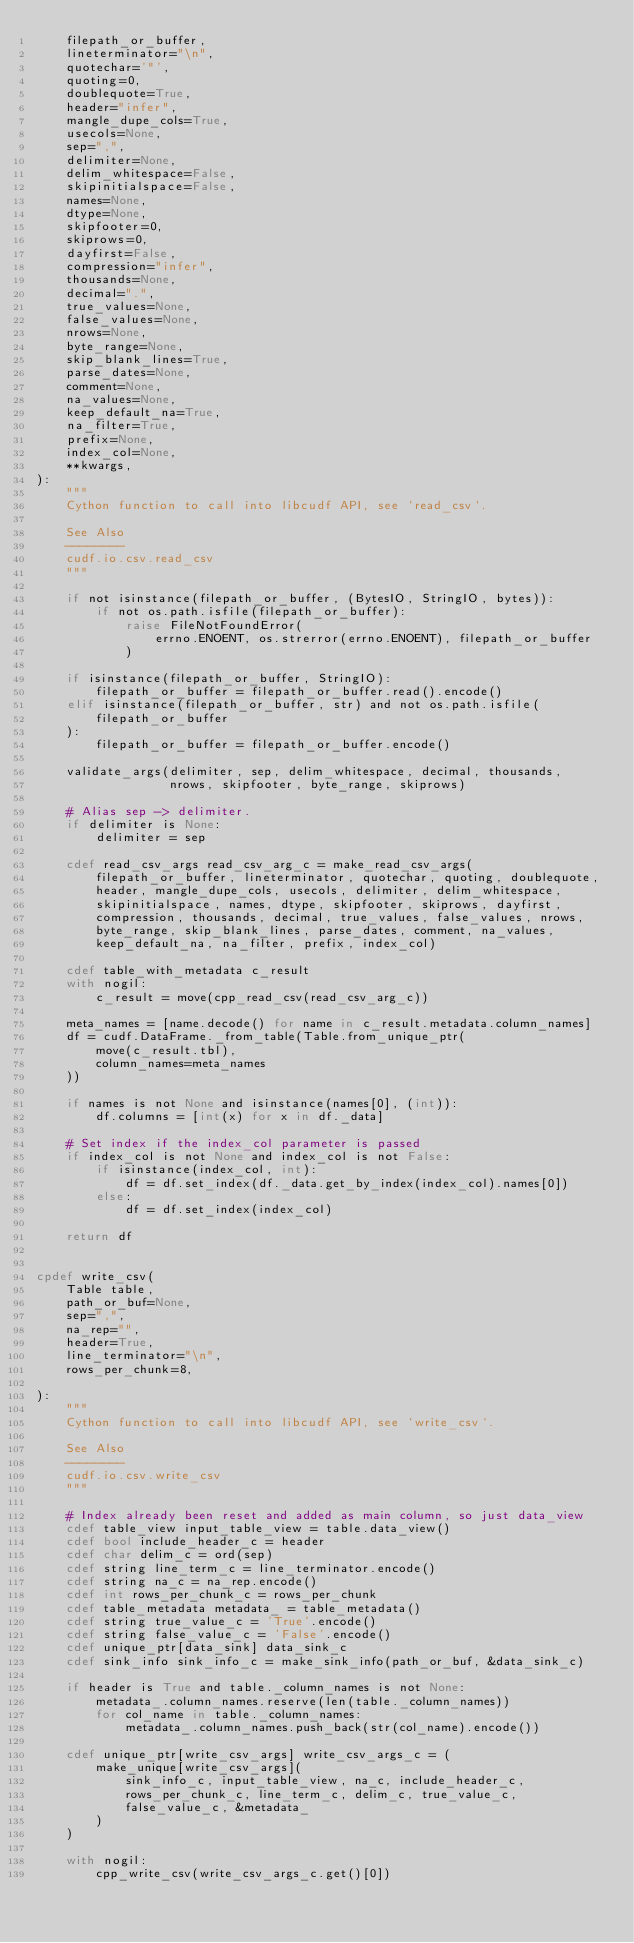<code> <loc_0><loc_0><loc_500><loc_500><_Cython_>    filepath_or_buffer,
    lineterminator="\n",
    quotechar='"',
    quoting=0,
    doublequote=True,
    header="infer",
    mangle_dupe_cols=True,
    usecols=None,
    sep=",",
    delimiter=None,
    delim_whitespace=False,
    skipinitialspace=False,
    names=None,
    dtype=None,
    skipfooter=0,
    skiprows=0,
    dayfirst=False,
    compression="infer",
    thousands=None,
    decimal=".",
    true_values=None,
    false_values=None,
    nrows=None,
    byte_range=None,
    skip_blank_lines=True,
    parse_dates=None,
    comment=None,
    na_values=None,
    keep_default_na=True,
    na_filter=True,
    prefix=None,
    index_col=None,
    **kwargs,
):
    """
    Cython function to call into libcudf API, see `read_csv`.

    See Also
    --------
    cudf.io.csv.read_csv
    """

    if not isinstance(filepath_or_buffer, (BytesIO, StringIO, bytes)):
        if not os.path.isfile(filepath_or_buffer):
            raise FileNotFoundError(
                errno.ENOENT, os.strerror(errno.ENOENT), filepath_or_buffer
            )

    if isinstance(filepath_or_buffer, StringIO):
        filepath_or_buffer = filepath_or_buffer.read().encode()
    elif isinstance(filepath_or_buffer, str) and not os.path.isfile(
        filepath_or_buffer
    ):
        filepath_or_buffer = filepath_or_buffer.encode()

    validate_args(delimiter, sep, delim_whitespace, decimal, thousands,
                  nrows, skipfooter, byte_range, skiprows)

    # Alias sep -> delimiter.
    if delimiter is None:
        delimiter = sep

    cdef read_csv_args read_csv_arg_c = make_read_csv_args(
        filepath_or_buffer, lineterminator, quotechar, quoting, doublequote,
        header, mangle_dupe_cols, usecols, delimiter, delim_whitespace,
        skipinitialspace, names, dtype, skipfooter, skiprows, dayfirst,
        compression, thousands, decimal, true_values, false_values, nrows,
        byte_range, skip_blank_lines, parse_dates, comment, na_values,
        keep_default_na, na_filter, prefix, index_col)

    cdef table_with_metadata c_result
    with nogil:
        c_result = move(cpp_read_csv(read_csv_arg_c))

    meta_names = [name.decode() for name in c_result.metadata.column_names]
    df = cudf.DataFrame._from_table(Table.from_unique_ptr(
        move(c_result.tbl),
        column_names=meta_names
    ))

    if names is not None and isinstance(names[0], (int)):
        df.columns = [int(x) for x in df._data]

    # Set index if the index_col parameter is passed
    if index_col is not None and index_col is not False:
        if isinstance(index_col, int):
            df = df.set_index(df._data.get_by_index(index_col).names[0])
        else:
            df = df.set_index(index_col)

    return df


cpdef write_csv(
    Table table,
    path_or_buf=None,
    sep=",",
    na_rep="",
    header=True,
    line_terminator="\n",
    rows_per_chunk=8,

):
    """
    Cython function to call into libcudf API, see `write_csv`.

    See Also
    --------
    cudf.io.csv.write_csv
    """

    # Index already been reset and added as main column, so just data_view
    cdef table_view input_table_view = table.data_view()
    cdef bool include_header_c = header
    cdef char delim_c = ord(sep)
    cdef string line_term_c = line_terminator.encode()
    cdef string na_c = na_rep.encode()
    cdef int rows_per_chunk_c = rows_per_chunk
    cdef table_metadata metadata_ = table_metadata()
    cdef string true_value_c = 'True'.encode()
    cdef string false_value_c = 'False'.encode()
    cdef unique_ptr[data_sink] data_sink_c
    cdef sink_info sink_info_c = make_sink_info(path_or_buf, &data_sink_c)

    if header is True and table._column_names is not None:
        metadata_.column_names.reserve(len(table._column_names))
        for col_name in table._column_names:
            metadata_.column_names.push_back(str(col_name).encode())

    cdef unique_ptr[write_csv_args] write_csv_args_c = (
        make_unique[write_csv_args](
            sink_info_c, input_table_view, na_c, include_header_c,
            rows_per_chunk_c, line_term_c, delim_c, true_value_c,
            false_value_c, &metadata_
        )
    )

    with nogil:
        cpp_write_csv(write_csv_args_c.get()[0])
</code> 